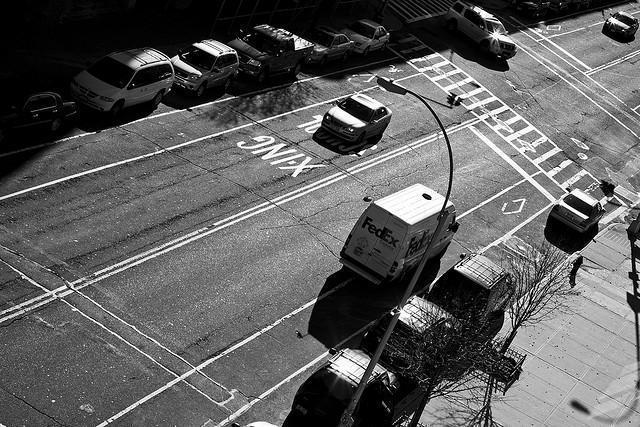How many trucks can you see?
Give a very brief answer. 4. How many cars are in the picture?
Give a very brief answer. 7. How many donuts are glazed?
Give a very brief answer. 0. 